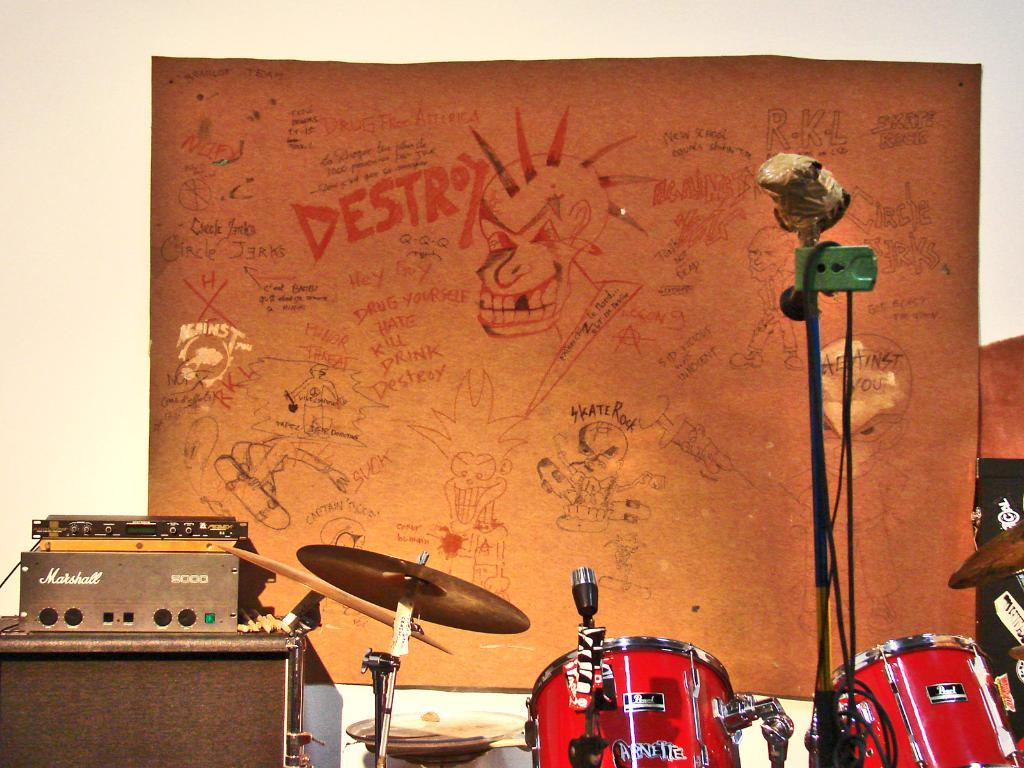<image>
Describe the image concisely. the backdrop for a band has lots of graffiti including Skate Rock and Destroy 